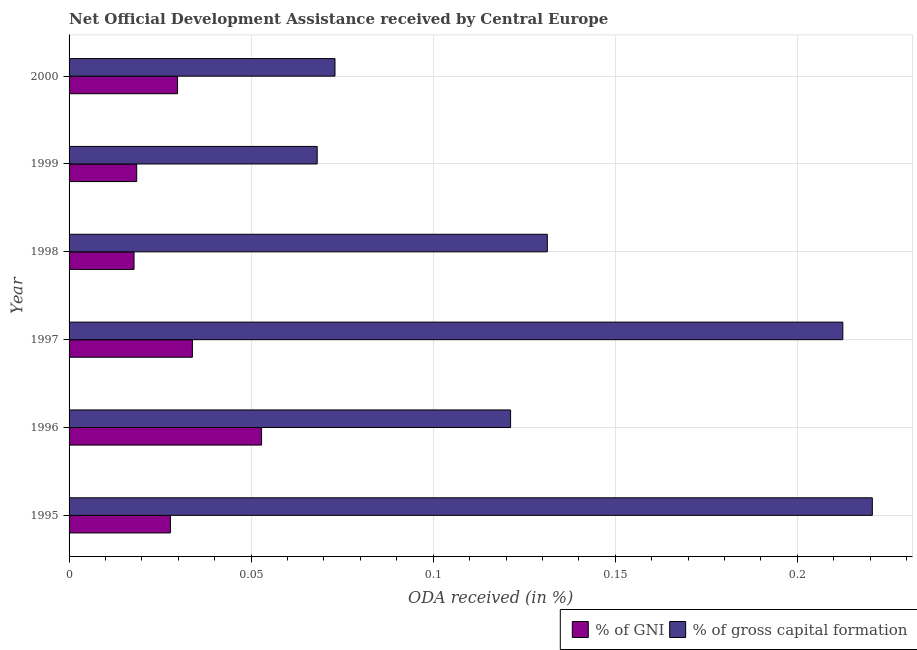How many bars are there on the 6th tick from the bottom?
Give a very brief answer. 2. What is the label of the 1st group of bars from the top?
Your answer should be compact. 2000. In how many cases, is the number of bars for a given year not equal to the number of legend labels?
Make the answer very short. 0. What is the oda received as percentage of gni in 1999?
Ensure brevity in your answer.  0.02. Across all years, what is the maximum oda received as percentage of gni?
Ensure brevity in your answer.  0.05. Across all years, what is the minimum oda received as percentage of gross capital formation?
Make the answer very short. 0.07. In which year was the oda received as percentage of gni maximum?
Offer a terse response. 1996. In which year was the oda received as percentage of gross capital formation minimum?
Offer a very short reply. 1999. What is the total oda received as percentage of gni in the graph?
Offer a very short reply. 0.18. What is the difference between the oda received as percentage of gross capital formation in 1995 and that in 1996?
Make the answer very short. 0.1. What is the difference between the oda received as percentage of gross capital formation in 2000 and the oda received as percentage of gni in 1996?
Give a very brief answer. 0.02. What is the average oda received as percentage of gross capital formation per year?
Ensure brevity in your answer.  0.14. In the year 1997, what is the difference between the oda received as percentage of gni and oda received as percentage of gross capital formation?
Make the answer very short. -0.18. In how many years, is the oda received as percentage of gross capital formation greater than 0.13 %?
Keep it short and to the point. 3. What is the ratio of the oda received as percentage of gni in 1998 to that in 2000?
Your answer should be very brief. 0.6. Is the oda received as percentage of gni in 1996 less than that in 1997?
Provide a succinct answer. No. What is the difference between the highest and the second highest oda received as percentage of gross capital formation?
Give a very brief answer. 0.01. What does the 1st bar from the top in 1998 represents?
Keep it short and to the point. % of gross capital formation. What does the 2nd bar from the bottom in 1996 represents?
Keep it short and to the point. % of gross capital formation. How many bars are there?
Your answer should be compact. 12. Are all the bars in the graph horizontal?
Ensure brevity in your answer.  Yes. Are the values on the major ticks of X-axis written in scientific E-notation?
Ensure brevity in your answer.  No. Does the graph contain any zero values?
Offer a very short reply. No. Does the graph contain grids?
Your answer should be compact. Yes. Where does the legend appear in the graph?
Ensure brevity in your answer.  Bottom right. How are the legend labels stacked?
Ensure brevity in your answer.  Horizontal. What is the title of the graph?
Your answer should be compact. Net Official Development Assistance received by Central Europe. What is the label or title of the X-axis?
Your answer should be compact. ODA received (in %). What is the ODA received (in %) of % of GNI in 1995?
Offer a terse response. 0.03. What is the ODA received (in %) of % of gross capital formation in 1995?
Provide a succinct answer. 0.22. What is the ODA received (in %) in % of GNI in 1996?
Keep it short and to the point. 0.05. What is the ODA received (in %) in % of gross capital formation in 1996?
Ensure brevity in your answer.  0.12. What is the ODA received (in %) of % of GNI in 1997?
Offer a very short reply. 0.03. What is the ODA received (in %) in % of gross capital formation in 1997?
Provide a succinct answer. 0.21. What is the ODA received (in %) in % of GNI in 1998?
Offer a very short reply. 0.02. What is the ODA received (in %) in % of gross capital formation in 1998?
Keep it short and to the point. 0.13. What is the ODA received (in %) of % of GNI in 1999?
Make the answer very short. 0.02. What is the ODA received (in %) of % of gross capital formation in 1999?
Keep it short and to the point. 0.07. What is the ODA received (in %) of % of GNI in 2000?
Ensure brevity in your answer.  0.03. What is the ODA received (in %) of % of gross capital formation in 2000?
Offer a very short reply. 0.07. Across all years, what is the maximum ODA received (in %) in % of GNI?
Your answer should be compact. 0.05. Across all years, what is the maximum ODA received (in %) in % of gross capital formation?
Give a very brief answer. 0.22. Across all years, what is the minimum ODA received (in %) in % of GNI?
Make the answer very short. 0.02. Across all years, what is the minimum ODA received (in %) of % of gross capital formation?
Your answer should be very brief. 0.07. What is the total ODA received (in %) in % of GNI in the graph?
Keep it short and to the point. 0.18. What is the total ODA received (in %) of % of gross capital formation in the graph?
Offer a very short reply. 0.83. What is the difference between the ODA received (in %) of % of GNI in 1995 and that in 1996?
Make the answer very short. -0.03. What is the difference between the ODA received (in %) in % of gross capital formation in 1995 and that in 1996?
Make the answer very short. 0.1. What is the difference between the ODA received (in %) in % of GNI in 1995 and that in 1997?
Give a very brief answer. -0.01. What is the difference between the ODA received (in %) in % of gross capital formation in 1995 and that in 1997?
Your response must be concise. 0.01. What is the difference between the ODA received (in %) of % of GNI in 1995 and that in 1998?
Give a very brief answer. 0.01. What is the difference between the ODA received (in %) of % of gross capital formation in 1995 and that in 1998?
Your answer should be compact. 0.09. What is the difference between the ODA received (in %) of % of GNI in 1995 and that in 1999?
Offer a terse response. 0.01. What is the difference between the ODA received (in %) of % of gross capital formation in 1995 and that in 1999?
Provide a short and direct response. 0.15. What is the difference between the ODA received (in %) of % of GNI in 1995 and that in 2000?
Your answer should be very brief. -0. What is the difference between the ODA received (in %) of % of gross capital formation in 1995 and that in 2000?
Your response must be concise. 0.15. What is the difference between the ODA received (in %) of % of GNI in 1996 and that in 1997?
Your response must be concise. 0.02. What is the difference between the ODA received (in %) in % of gross capital formation in 1996 and that in 1997?
Ensure brevity in your answer.  -0.09. What is the difference between the ODA received (in %) in % of GNI in 1996 and that in 1998?
Offer a terse response. 0.04. What is the difference between the ODA received (in %) of % of gross capital formation in 1996 and that in 1998?
Ensure brevity in your answer.  -0.01. What is the difference between the ODA received (in %) in % of GNI in 1996 and that in 1999?
Provide a short and direct response. 0.03. What is the difference between the ODA received (in %) in % of gross capital formation in 1996 and that in 1999?
Provide a succinct answer. 0.05. What is the difference between the ODA received (in %) in % of GNI in 1996 and that in 2000?
Ensure brevity in your answer.  0.02. What is the difference between the ODA received (in %) in % of gross capital formation in 1996 and that in 2000?
Ensure brevity in your answer.  0.05. What is the difference between the ODA received (in %) in % of GNI in 1997 and that in 1998?
Ensure brevity in your answer.  0.02. What is the difference between the ODA received (in %) in % of gross capital formation in 1997 and that in 1998?
Make the answer very short. 0.08. What is the difference between the ODA received (in %) of % of GNI in 1997 and that in 1999?
Provide a succinct answer. 0.02. What is the difference between the ODA received (in %) of % of gross capital formation in 1997 and that in 1999?
Give a very brief answer. 0.14. What is the difference between the ODA received (in %) in % of GNI in 1997 and that in 2000?
Your answer should be compact. 0. What is the difference between the ODA received (in %) of % of gross capital formation in 1997 and that in 2000?
Provide a short and direct response. 0.14. What is the difference between the ODA received (in %) of % of GNI in 1998 and that in 1999?
Provide a succinct answer. -0. What is the difference between the ODA received (in %) in % of gross capital formation in 1998 and that in 1999?
Offer a terse response. 0.06. What is the difference between the ODA received (in %) in % of GNI in 1998 and that in 2000?
Offer a terse response. -0.01. What is the difference between the ODA received (in %) in % of gross capital formation in 1998 and that in 2000?
Give a very brief answer. 0.06. What is the difference between the ODA received (in %) in % of GNI in 1999 and that in 2000?
Provide a short and direct response. -0.01. What is the difference between the ODA received (in %) of % of gross capital formation in 1999 and that in 2000?
Ensure brevity in your answer.  -0. What is the difference between the ODA received (in %) of % of GNI in 1995 and the ODA received (in %) of % of gross capital formation in 1996?
Your response must be concise. -0.09. What is the difference between the ODA received (in %) in % of GNI in 1995 and the ODA received (in %) in % of gross capital formation in 1997?
Offer a very short reply. -0.18. What is the difference between the ODA received (in %) in % of GNI in 1995 and the ODA received (in %) in % of gross capital formation in 1998?
Provide a short and direct response. -0.1. What is the difference between the ODA received (in %) of % of GNI in 1995 and the ODA received (in %) of % of gross capital formation in 1999?
Keep it short and to the point. -0.04. What is the difference between the ODA received (in %) of % of GNI in 1995 and the ODA received (in %) of % of gross capital formation in 2000?
Make the answer very short. -0.05. What is the difference between the ODA received (in %) of % of GNI in 1996 and the ODA received (in %) of % of gross capital formation in 1997?
Provide a succinct answer. -0.16. What is the difference between the ODA received (in %) of % of GNI in 1996 and the ODA received (in %) of % of gross capital formation in 1998?
Offer a terse response. -0.08. What is the difference between the ODA received (in %) in % of GNI in 1996 and the ODA received (in %) in % of gross capital formation in 1999?
Provide a short and direct response. -0.02. What is the difference between the ODA received (in %) of % of GNI in 1996 and the ODA received (in %) of % of gross capital formation in 2000?
Provide a short and direct response. -0.02. What is the difference between the ODA received (in %) in % of GNI in 1997 and the ODA received (in %) in % of gross capital formation in 1998?
Keep it short and to the point. -0.1. What is the difference between the ODA received (in %) of % of GNI in 1997 and the ODA received (in %) of % of gross capital formation in 1999?
Make the answer very short. -0.03. What is the difference between the ODA received (in %) in % of GNI in 1997 and the ODA received (in %) in % of gross capital formation in 2000?
Your response must be concise. -0.04. What is the difference between the ODA received (in %) of % of GNI in 1998 and the ODA received (in %) of % of gross capital formation in 1999?
Make the answer very short. -0.05. What is the difference between the ODA received (in %) of % of GNI in 1998 and the ODA received (in %) of % of gross capital formation in 2000?
Offer a terse response. -0.06. What is the difference between the ODA received (in %) of % of GNI in 1999 and the ODA received (in %) of % of gross capital formation in 2000?
Provide a short and direct response. -0.05. What is the average ODA received (in %) in % of GNI per year?
Provide a short and direct response. 0.03. What is the average ODA received (in %) in % of gross capital formation per year?
Offer a terse response. 0.14. In the year 1995, what is the difference between the ODA received (in %) of % of GNI and ODA received (in %) of % of gross capital formation?
Provide a short and direct response. -0.19. In the year 1996, what is the difference between the ODA received (in %) of % of GNI and ODA received (in %) of % of gross capital formation?
Offer a very short reply. -0.07. In the year 1997, what is the difference between the ODA received (in %) of % of GNI and ODA received (in %) of % of gross capital formation?
Make the answer very short. -0.18. In the year 1998, what is the difference between the ODA received (in %) of % of GNI and ODA received (in %) of % of gross capital formation?
Ensure brevity in your answer.  -0.11. In the year 1999, what is the difference between the ODA received (in %) of % of GNI and ODA received (in %) of % of gross capital formation?
Keep it short and to the point. -0.05. In the year 2000, what is the difference between the ODA received (in %) in % of GNI and ODA received (in %) in % of gross capital formation?
Provide a short and direct response. -0.04. What is the ratio of the ODA received (in %) of % of GNI in 1995 to that in 1996?
Make the answer very short. 0.53. What is the ratio of the ODA received (in %) in % of gross capital formation in 1995 to that in 1996?
Offer a very short reply. 1.82. What is the ratio of the ODA received (in %) in % of GNI in 1995 to that in 1997?
Your answer should be compact. 0.82. What is the ratio of the ODA received (in %) in % of gross capital formation in 1995 to that in 1997?
Your answer should be very brief. 1.04. What is the ratio of the ODA received (in %) of % of GNI in 1995 to that in 1998?
Give a very brief answer. 1.56. What is the ratio of the ODA received (in %) in % of gross capital formation in 1995 to that in 1998?
Make the answer very short. 1.68. What is the ratio of the ODA received (in %) in % of GNI in 1995 to that in 1999?
Your response must be concise. 1.5. What is the ratio of the ODA received (in %) of % of gross capital formation in 1995 to that in 1999?
Provide a succinct answer. 3.24. What is the ratio of the ODA received (in %) in % of GNI in 1995 to that in 2000?
Ensure brevity in your answer.  0.93. What is the ratio of the ODA received (in %) of % of gross capital formation in 1995 to that in 2000?
Make the answer very short. 3.02. What is the ratio of the ODA received (in %) of % of GNI in 1996 to that in 1997?
Keep it short and to the point. 1.56. What is the ratio of the ODA received (in %) of % of gross capital formation in 1996 to that in 1997?
Keep it short and to the point. 0.57. What is the ratio of the ODA received (in %) of % of GNI in 1996 to that in 1998?
Ensure brevity in your answer.  2.96. What is the ratio of the ODA received (in %) in % of gross capital formation in 1996 to that in 1998?
Keep it short and to the point. 0.92. What is the ratio of the ODA received (in %) in % of GNI in 1996 to that in 1999?
Offer a very short reply. 2.85. What is the ratio of the ODA received (in %) in % of gross capital formation in 1996 to that in 1999?
Your answer should be very brief. 1.78. What is the ratio of the ODA received (in %) in % of GNI in 1996 to that in 2000?
Ensure brevity in your answer.  1.77. What is the ratio of the ODA received (in %) of % of gross capital formation in 1996 to that in 2000?
Offer a very short reply. 1.66. What is the ratio of the ODA received (in %) of % of GNI in 1997 to that in 1998?
Ensure brevity in your answer.  1.9. What is the ratio of the ODA received (in %) of % of gross capital formation in 1997 to that in 1998?
Keep it short and to the point. 1.62. What is the ratio of the ODA received (in %) in % of GNI in 1997 to that in 1999?
Make the answer very short. 1.82. What is the ratio of the ODA received (in %) of % of gross capital formation in 1997 to that in 1999?
Your answer should be compact. 3.12. What is the ratio of the ODA received (in %) of % of GNI in 1997 to that in 2000?
Your response must be concise. 1.14. What is the ratio of the ODA received (in %) in % of gross capital formation in 1997 to that in 2000?
Offer a terse response. 2.91. What is the ratio of the ODA received (in %) of % of GNI in 1998 to that in 1999?
Your response must be concise. 0.96. What is the ratio of the ODA received (in %) in % of gross capital formation in 1998 to that in 1999?
Offer a terse response. 1.93. What is the ratio of the ODA received (in %) in % of GNI in 1998 to that in 2000?
Give a very brief answer. 0.6. What is the ratio of the ODA received (in %) of % of gross capital formation in 1998 to that in 2000?
Provide a succinct answer. 1.8. What is the ratio of the ODA received (in %) of % of GNI in 1999 to that in 2000?
Your answer should be compact. 0.62. What is the ratio of the ODA received (in %) in % of gross capital formation in 1999 to that in 2000?
Keep it short and to the point. 0.93. What is the difference between the highest and the second highest ODA received (in %) of % of GNI?
Provide a short and direct response. 0.02. What is the difference between the highest and the second highest ODA received (in %) of % of gross capital formation?
Your answer should be compact. 0.01. What is the difference between the highest and the lowest ODA received (in %) in % of GNI?
Your response must be concise. 0.04. What is the difference between the highest and the lowest ODA received (in %) in % of gross capital formation?
Your answer should be very brief. 0.15. 